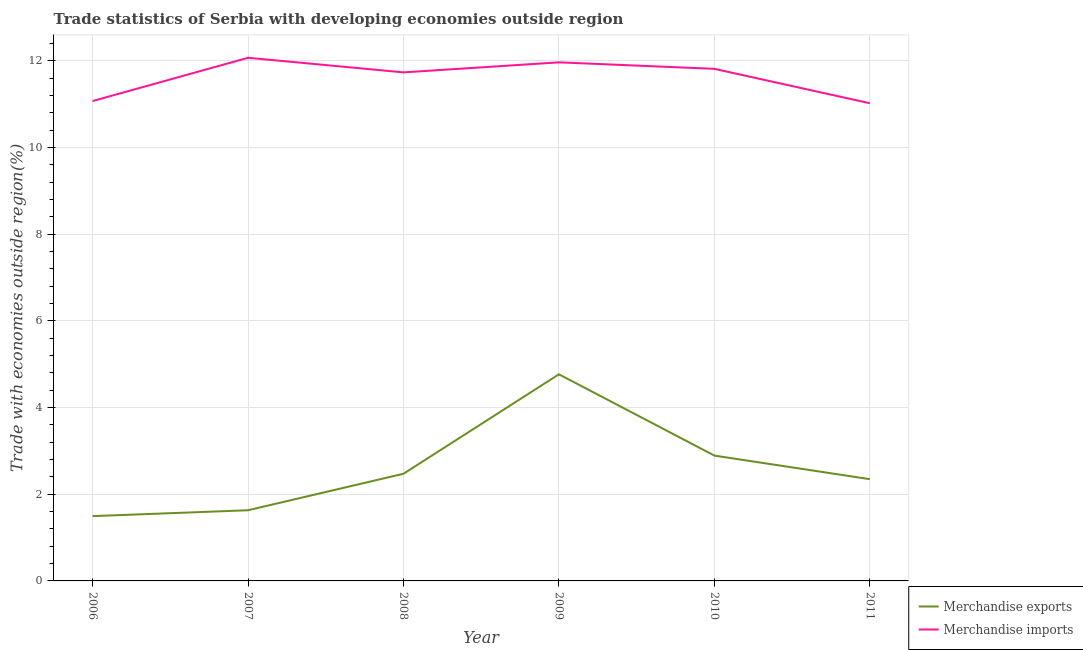How many different coloured lines are there?
Your answer should be very brief. 2. What is the merchandise exports in 2007?
Your answer should be very brief. 1.63. Across all years, what is the maximum merchandise exports?
Provide a succinct answer. 4.77. Across all years, what is the minimum merchandise exports?
Offer a very short reply. 1.5. In which year was the merchandise exports maximum?
Offer a terse response. 2009. What is the total merchandise imports in the graph?
Your answer should be very brief. 69.68. What is the difference between the merchandise exports in 2007 and that in 2010?
Provide a short and direct response. -1.26. What is the difference between the merchandise imports in 2006 and the merchandise exports in 2009?
Offer a very short reply. 6.3. What is the average merchandise exports per year?
Make the answer very short. 2.6. In the year 2006, what is the difference between the merchandise imports and merchandise exports?
Keep it short and to the point. 9.58. What is the ratio of the merchandise imports in 2010 to that in 2011?
Offer a terse response. 1.07. Is the merchandise imports in 2008 less than that in 2009?
Offer a very short reply. Yes. Is the difference between the merchandise exports in 2009 and 2010 greater than the difference between the merchandise imports in 2009 and 2010?
Make the answer very short. Yes. What is the difference between the highest and the second highest merchandise imports?
Offer a very short reply. 0.11. What is the difference between the highest and the lowest merchandise imports?
Make the answer very short. 1.05. Is the sum of the merchandise imports in 2006 and 2009 greater than the maximum merchandise exports across all years?
Make the answer very short. Yes. Is the merchandise exports strictly greater than the merchandise imports over the years?
Your answer should be very brief. No. How many lines are there?
Provide a succinct answer. 2. How many years are there in the graph?
Give a very brief answer. 6. What is the difference between two consecutive major ticks on the Y-axis?
Offer a terse response. 2. Are the values on the major ticks of Y-axis written in scientific E-notation?
Provide a short and direct response. No. Does the graph contain grids?
Give a very brief answer. Yes. How many legend labels are there?
Ensure brevity in your answer.  2. How are the legend labels stacked?
Provide a short and direct response. Vertical. What is the title of the graph?
Provide a short and direct response. Trade statistics of Serbia with developing economies outside region. Does "Total Population" appear as one of the legend labels in the graph?
Make the answer very short. No. What is the label or title of the X-axis?
Make the answer very short. Year. What is the label or title of the Y-axis?
Provide a short and direct response. Trade with economies outside region(%). What is the Trade with economies outside region(%) of Merchandise exports in 2006?
Offer a terse response. 1.5. What is the Trade with economies outside region(%) of Merchandise imports in 2006?
Keep it short and to the point. 11.07. What is the Trade with economies outside region(%) in Merchandise exports in 2007?
Provide a short and direct response. 1.63. What is the Trade with economies outside region(%) of Merchandise imports in 2007?
Provide a short and direct response. 12.07. What is the Trade with economies outside region(%) in Merchandise exports in 2008?
Your answer should be compact. 2.47. What is the Trade with economies outside region(%) in Merchandise imports in 2008?
Your answer should be very brief. 11.73. What is the Trade with economies outside region(%) in Merchandise exports in 2009?
Make the answer very short. 4.77. What is the Trade with economies outside region(%) in Merchandise imports in 2009?
Provide a short and direct response. 11.97. What is the Trade with economies outside region(%) of Merchandise exports in 2010?
Keep it short and to the point. 2.89. What is the Trade with economies outside region(%) of Merchandise imports in 2010?
Offer a very short reply. 11.82. What is the Trade with economies outside region(%) of Merchandise exports in 2011?
Offer a very short reply. 2.35. What is the Trade with economies outside region(%) of Merchandise imports in 2011?
Provide a short and direct response. 11.02. Across all years, what is the maximum Trade with economies outside region(%) in Merchandise exports?
Keep it short and to the point. 4.77. Across all years, what is the maximum Trade with economies outside region(%) of Merchandise imports?
Ensure brevity in your answer.  12.07. Across all years, what is the minimum Trade with economies outside region(%) in Merchandise exports?
Offer a terse response. 1.5. Across all years, what is the minimum Trade with economies outside region(%) of Merchandise imports?
Your answer should be compact. 11.02. What is the total Trade with economies outside region(%) of Merchandise exports in the graph?
Provide a succinct answer. 15.61. What is the total Trade with economies outside region(%) in Merchandise imports in the graph?
Give a very brief answer. 69.68. What is the difference between the Trade with economies outside region(%) in Merchandise exports in 2006 and that in 2007?
Provide a succinct answer. -0.14. What is the difference between the Trade with economies outside region(%) in Merchandise imports in 2006 and that in 2007?
Provide a short and direct response. -1. What is the difference between the Trade with economies outside region(%) of Merchandise exports in 2006 and that in 2008?
Your response must be concise. -0.98. What is the difference between the Trade with economies outside region(%) in Merchandise imports in 2006 and that in 2008?
Your answer should be very brief. -0.66. What is the difference between the Trade with economies outside region(%) in Merchandise exports in 2006 and that in 2009?
Offer a very short reply. -3.27. What is the difference between the Trade with economies outside region(%) of Merchandise imports in 2006 and that in 2009?
Keep it short and to the point. -0.89. What is the difference between the Trade with economies outside region(%) of Merchandise exports in 2006 and that in 2010?
Offer a terse response. -1.4. What is the difference between the Trade with economies outside region(%) of Merchandise imports in 2006 and that in 2010?
Your response must be concise. -0.74. What is the difference between the Trade with economies outside region(%) in Merchandise exports in 2006 and that in 2011?
Your answer should be compact. -0.85. What is the difference between the Trade with economies outside region(%) in Merchandise imports in 2006 and that in 2011?
Ensure brevity in your answer.  0.05. What is the difference between the Trade with economies outside region(%) of Merchandise exports in 2007 and that in 2008?
Give a very brief answer. -0.84. What is the difference between the Trade with economies outside region(%) in Merchandise imports in 2007 and that in 2008?
Make the answer very short. 0.34. What is the difference between the Trade with economies outside region(%) in Merchandise exports in 2007 and that in 2009?
Your answer should be compact. -3.14. What is the difference between the Trade with economies outside region(%) of Merchandise imports in 2007 and that in 2009?
Your answer should be very brief. 0.11. What is the difference between the Trade with economies outside region(%) of Merchandise exports in 2007 and that in 2010?
Offer a terse response. -1.26. What is the difference between the Trade with economies outside region(%) in Merchandise imports in 2007 and that in 2010?
Give a very brief answer. 0.26. What is the difference between the Trade with economies outside region(%) of Merchandise exports in 2007 and that in 2011?
Offer a terse response. -0.72. What is the difference between the Trade with economies outside region(%) in Merchandise imports in 2007 and that in 2011?
Your response must be concise. 1.05. What is the difference between the Trade with economies outside region(%) in Merchandise exports in 2008 and that in 2009?
Give a very brief answer. -2.29. What is the difference between the Trade with economies outside region(%) in Merchandise imports in 2008 and that in 2009?
Provide a short and direct response. -0.23. What is the difference between the Trade with economies outside region(%) of Merchandise exports in 2008 and that in 2010?
Ensure brevity in your answer.  -0.42. What is the difference between the Trade with economies outside region(%) in Merchandise imports in 2008 and that in 2010?
Provide a succinct answer. -0.08. What is the difference between the Trade with economies outside region(%) in Merchandise exports in 2008 and that in 2011?
Your answer should be compact. 0.13. What is the difference between the Trade with economies outside region(%) in Merchandise imports in 2008 and that in 2011?
Offer a terse response. 0.71. What is the difference between the Trade with economies outside region(%) in Merchandise exports in 2009 and that in 2010?
Ensure brevity in your answer.  1.88. What is the difference between the Trade with economies outside region(%) in Merchandise imports in 2009 and that in 2010?
Your answer should be compact. 0.15. What is the difference between the Trade with economies outside region(%) in Merchandise exports in 2009 and that in 2011?
Your answer should be very brief. 2.42. What is the difference between the Trade with economies outside region(%) of Merchandise imports in 2009 and that in 2011?
Keep it short and to the point. 0.94. What is the difference between the Trade with economies outside region(%) of Merchandise exports in 2010 and that in 2011?
Offer a very short reply. 0.54. What is the difference between the Trade with economies outside region(%) of Merchandise imports in 2010 and that in 2011?
Offer a terse response. 0.79. What is the difference between the Trade with economies outside region(%) in Merchandise exports in 2006 and the Trade with economies outside region(%) in Merchandise imports in 2007?
Your response must be concise. -10.58. What is the difference between the Trade with economies outside region(%) in Merchandise exports in 2006 and the Trade with economies outside region(%) in Merchandise imports in 2008?
Ensure brevity in your answer.  -10.24. What is the difference between the Trade with economies outside region(%) in Merchandise exports in 2006 and the Trade with economies outside region(%) in Merchandise imports in 2009?
Ensure brevity in your answer.  -10.47. What is the difference between the Trade with economies outside region(%) of Merchandise exports in 2006 and the Trade with economies outside region(%) of Merchandise imports in 2010?
Keep it short and to the point. -10.32. What is the difference between the Trade with economies outside region(%) in Merchandise exports in 2006 and the Trade with economies outside region(%) in Merchandise imports in 2011?
Make the answer very short. -9.53. What is the difference between the Trade with economies outside region(%) of Merchandise exports in 2007 and the Trade with economies outside region(%) of Merchandise imports in 2008?
Offer a terse response. -10.1. What is the difference between the Trade with economies outside region(%) of Merchandise exports in 2007 and the Trade with economies outside region(%) of Merchandise imports in 2009?
Provide a succinct answer. -10.33. What is the difference between the Trade with economies outside region(%) in Merchandise exports in 2007 and the Trade with economies outside region(%) in Merchandise imports in 2010?
Your answer should be compact. -10.18. What is the difference between the Trade with economies outside region(%) of Merchandise exports in 2007 and the Trade with economies outside region(%) of Merchandise imports in 2011?
Your answer should be compact. -9.39. What is the difference between the Trade with economies outside region(%) in Merchandise exports in 2008 and the Trade with economies outside region(%) in Merchandise imports in 2009?
Make the answer very short. -9.49. What is the difference between the Trade with economies outside region(%) of Merchandise exports in 2008 and the Trade with economies outside region(%) of Merchandise imports in 2010?
Keep it short and to the point. -9.34. What is the difference between the Trade with economies outside region(%) of Merchandise exports in 2008 and the Trade with economies outside region(%) of Merchandise imports in 2011?
Offer a very short reply. -8.55. What is the difference between the Trade with economies outside region(%) of Merchandise exports in 2009 and the Trade with economies outside region(%) of Merchandise imports in 2010?
Provide a short and direct response. -7.05. What is the difference between the Trade with economies outside region(%) in Merchandise exports in 2009 and the Trade with economies outside region(%) in Merchandise imports in 2011?
Make the answer very short. -6.25. What is the difference between the Trade with economies outside region(%) of Merchandise exports in 2010 and the Trade with economies outside region(%) of Merchandise imports in 2011?
Give a very brief answer. -8.13. What is the average Trade with economies outside region(%) in Merchandise exports per year?
Offer a very short reply. 2.6. What is the average Trade with economies outside region(%) in Merchandise imports per year?
Provide a short and direct response. 11.61. In the year 2006, what is the difference between the Trade with economies outside region(%) of Merchandise exports and Trade with economies outside region(%) of Merchandise imports?
Provide a short and direct response. -9.58. In the year 2007, what is the difference between the Trade with economies outside region(%) in Merchandise exports and Trade with economies outside region(%) in Merchandise imports?
Your answer should be very brief. -10.44. In the year 2008, what is the difference between the Trade with economies outside region(%) of Merchandise exports and Trade with economies outside region(%) of Merchandise imports?
Ensure brevity in your answer.  -9.26. In the year 2009, what is the difference between the Trade with economies outside region(%) in Merchandise exports and Trade with economies outside region(%) in Merchandise imports?
Your answer should be compact. -7.2. In the year 2010, what is the difference between the Trade with economies outside region(%) in Merchandise exports and Trade with economies outside region(%) in Merchandise imports?
Provide a short and direct response. -8.92. In the year 2011, what is the difference between the Trade with economies outside region(%) in Merchandise exports and Trade with economies outside region(%) in Merchandise imports?
Offer a terse response. -8.67. What is the ratio of the Trade with economies outside region(%) in Merchandise exports in 2006 to that in 2007?
Your response must be concise. 0.92. What is the ratio of the Trade with economies outside region(%) of Merchandise imports in 2006 to that in 2007?
Provide a succinct answer. 0.92. What is the ratio of the Trade with economies outside region(%) in Merchandise exports in 2006 to that in 2008?
Your answer should be compact. 0.6. What is the ratio of the Trade with economies outside region(%) in Merchandise imports in 2006 to that in 2008?
Make the answer very short. 0.94. What is the ratio of the Trade with economies outside region(%) in Merchandise exports in 2006 to that in 2009?
Keep it short and to the point. 0.31. What is the ratio of the Trade with economies outside region(%) in Merchandise imports in 2006 to that in 2009?
Offer a very short reply. 0.93. What is the ratio of the Trade with economies outside region(%) of Merchandise exports in 2006 to that in 2010?
Provide a succinct answer. 0.52. What is the ratio of the Trade with economies outside region(%) in Merchandise imports in 2006 to that in 2010?
Offer a very short reply. 0.94. What is the ratio of the Trade with economies outside region(%) in Merchandise exports in 2006 to that in 2011?
Your answer should be compact. 0.64. What is the ratio of the Trade with economies outside region(%) of Merchandise exports in 2007 to that in 2008?
Offer a very short reply. 0.66. What is the ratio of the Trade with economies outside region(%) in Merchandise imports in 2007 to that in 2008?
Provide a short and direct response. 1.03. What is the ratio of the Trade with economies outside region(%) in Merchandise exports in 2007 to that in 2009?
Make the answer very short. 0.34. What is the ratio of the Trade with economies outside region(%) of Merchandise imports in 2007 to that in 2009?
Ensure brevity in your answer.  1.01. What is the ratio of the Trade with economies outside region(%) in Merchandise exports in 2007 to that in 2010?
Ensure brevity in your answer.  0.56. What is the ratio of the Trade with economies outside region(%) in Merchandise imports in 2007 to that in 2010?
Your response must be concise. 1.02. What is the ratio of the Trade with economies outside region(%) in Merchandise exports in 2007 to that in 2011?
Provide a short and direct response. 0.69. What is the ratio of the Trade with economies outside region(%) of Merchandise imports in 2007 to that in 2011?
Offer a terse response. 1.1. What is the ratio of the Trade with economies outside region(%) in Merchandise exports in 2008 to that in 2009?
Offer a terse response. 0.52. What is the ratio of the Trade with economies outside region(%) in Merchandise imports in 2008 to that in 2009?
Offer a terse response. 0.98. What is the ratio of the Trade with economies outside region(%) in Merchandise exports in 2008 to that in 2010?
Provide a succinct answer. 0.86. What is the ratio of the Trade with economies outside region(%) in Merchandise exports in 2008 to that in 2011?
Offer a very short reply. 1.05. What is the ratio of the Trade with economies outside region(%) of Merchandise imports in 2008 to that in 2011?
Provide a succinct answer. 1.06. What is the ratio of the Trade with economies outside region(%) of Merchandise exports in 2009 to that in 2010?
Provide a short and direct response. 1.65. What is the ratio of the Trade with economies outside region(%) in Merchandise imports in 2009 to that in 2010?
Offer a very short reply. 1.01. What is the ratio of the Trade with economies outside region(%) of Merchandise exports in 2009 to that in 2011?
Offer a very short reply. 2.03. What is the ratio of the Trade with economies outside region(%) of Merchandise imports in 2009 to that in 2011?
Provide a succinct answer. 1.09. What is the ratio of the Trade with economies outside region(%) in Merchandise exports in 2010 to that in 2011?
Provide a succinct answer. 1.23. What is the ratio of the Trade with economies outside region(%) of Merchandise imports in 2010 to that in 2011?
Offer a very short reply. 1.07. What is the difference between the highest and the second highest Trade with economies outside region(%) in Merchandise exports?
Offer a very short reply. 1.88. What is the difference between the highest and the second highest Trade with economies outside region(%) in Merchandise imports?
Offer a terse response. 0.11. What is the difference between the highest and the lowest Trade with economies outside region(%) of Merchandise exports?
Ensure brevity in your answer.  3.27. What is the difference between the highest and the lowest Trade with economies outside region(%) of Merchandise imports?
Provide a succinct answer. 1.05. 